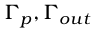<formula> <loc_0><loc_0><loc_500><loc_500>\Gamma _ { p } , \Gamma _ { o u t }</formula> 